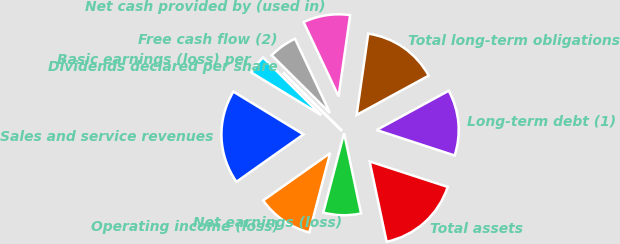Convert chart to OTSL. <chart><loc_0><loc_0><loc_500><loc_500><pie_chart><fcel>Sales and service revenues<fcel>Operating income (loss)<fcel>Net earnings (loss)<fcel>Total assets<fcel>Long-term debt (1)<fcel>Total long-term obligations<fcel>Net cash provided by (used in)<fcel>Free cash flow (2)<fcel>Dividends declared per share<fcel>Basic earnings (loss) per<nl><fcel>18.51%<fcel>11.11%<fcel>7.41%<fcel>16.66%<fcel>12.96%<fcel>14.81%<fcel>9.26%<fcel>5.56%<fcel>0.01%<fcel>3.71%<nl></chart> 